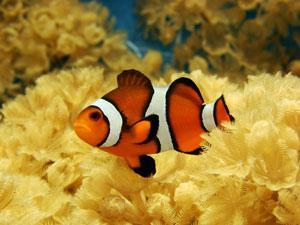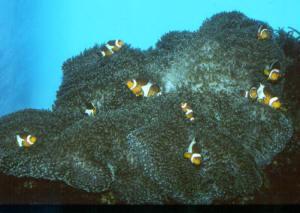The first image is the image on the left, the second image is the image on the right. For the images displayed, is the sentence "The left image contains at least one clown fish with white stripes." factually correct? Answer yes or no. Yes. 